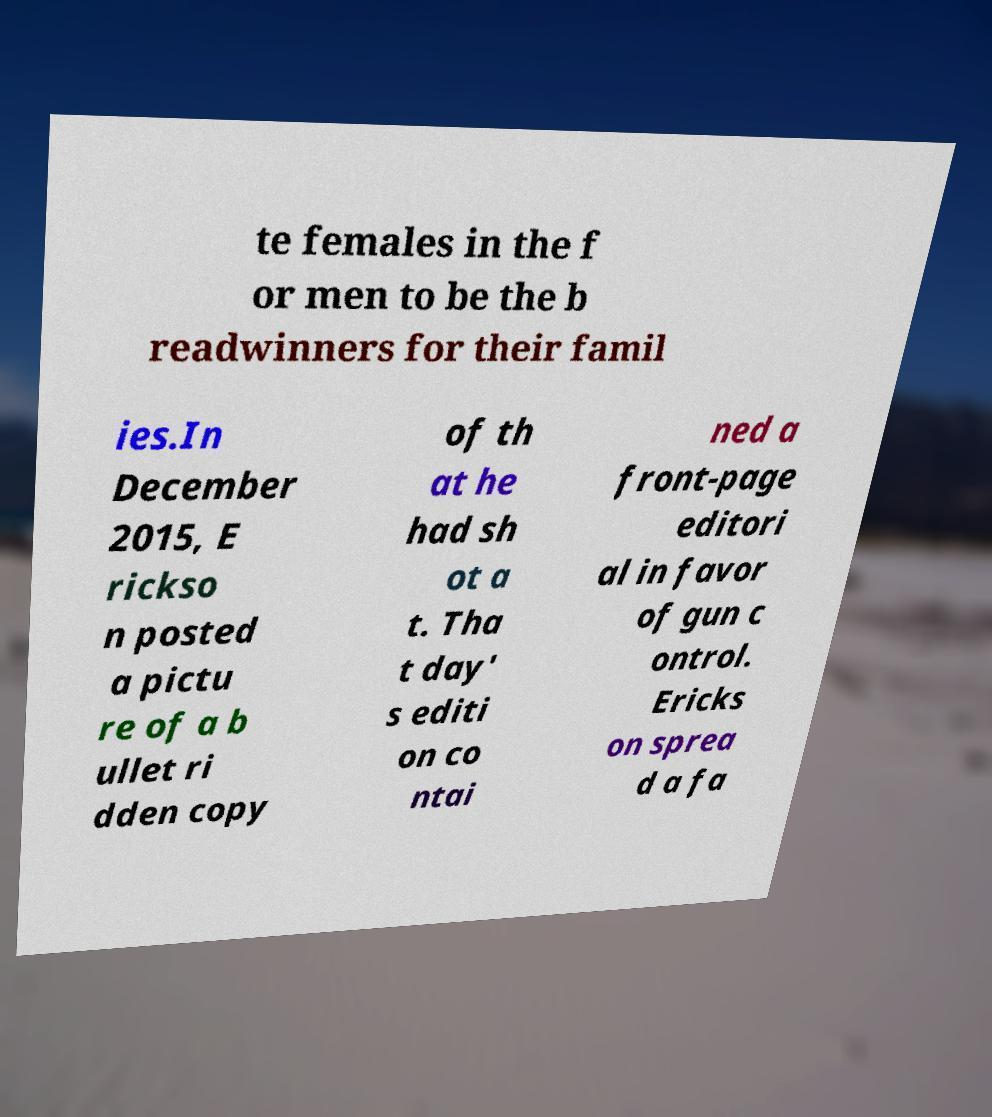I need the written content from this picture converted into text. Can you do that? te females in the f or men to be the b readwinners for their famil ies.In December 2015, E rickso n posted a pictu re of a b ullet ri dden copy of th at he had sh ot a t. Tha t day' s editi on co ntai ned a front-page editori al in favor of gun c ontrol. Ericks on sprea d a fa 